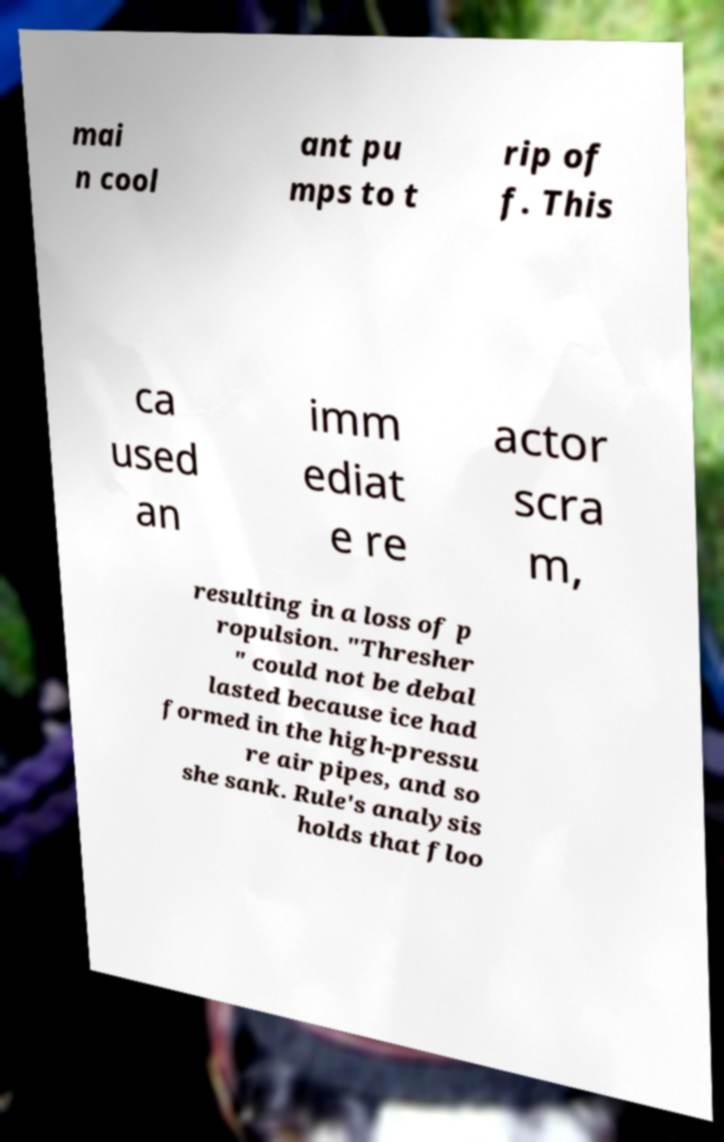Please read and relay the text visible in this image. What does it say? mai n cool ant pu mps to t rip of f. This ca used an imm ediat e re actor scra m, resulting in a loss of p ropulsion. "Thresher " could not be debal lasted because ice had formed in the high-pressu re air pipes, and so she sank. Rule's analysis holds that floo 